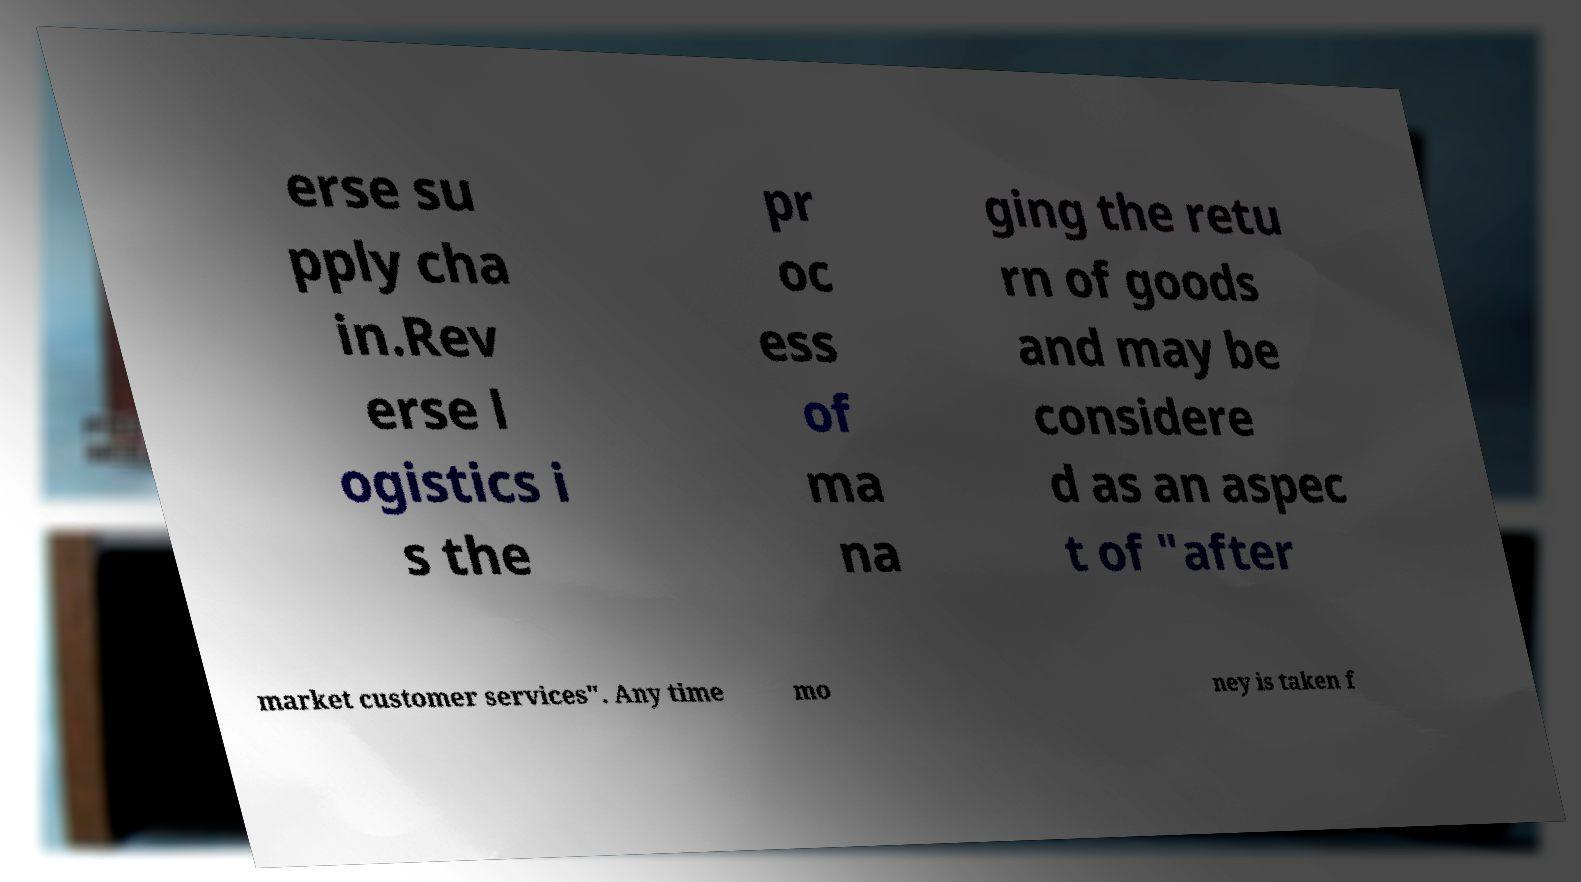Please read and relay the text visible in this image. What does it say? erse su pply cha in.Rev erse l ogistics i s the pr oc ess of ma na ging the retu rn of goods and may be considere d as an aspec t of "after market customer services". Any time mo ney is taken f 